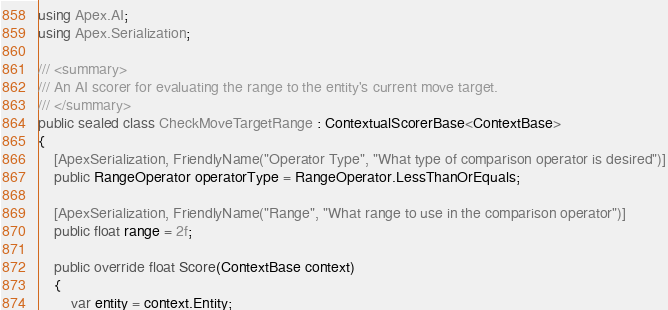Convert code to text. <code><loc_0><loc_0><loc_500><loc_500><_C#_>using Apex.AI;
using Apex.Serialization;

/// <summary>
/// An AI scorer for evaluating the range to the entity's current move target.
/// </summary>
public sealed class CheckMoveTargetRange : ContextualScorerBase<ContextBase>
{
    [ApexSerialization, FriendlyName("Operator Type", "What type of comparison operator is desired")]
    public RangeOperator operatorType = RangeOperator.LessThanOrEquals;

    [ApexSerialization, FriendlyName("Range", "What range to use in the comparison operator")]
    public float range = 2f;

    public override float Score(ContextBase context)
    {
        var entity = context.Entity;
</code> 